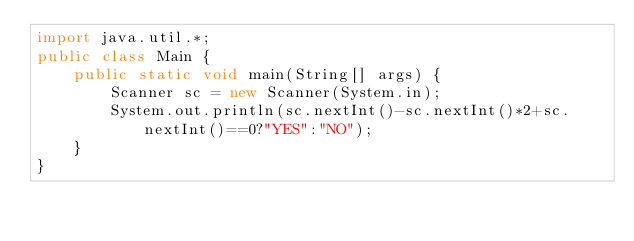<code> <loc_0><loc_0><loc_500><loc_500><_Java_>import java.util.*;
public class Main {
    public static void main(String[] args) {
        Scanner sc = new Scanner(System.in);
        System.out.println(sc.nextInt()-sc.nextInt()*2+sc.nextInt()==0?"YES":"NO");
    }
}</code> 